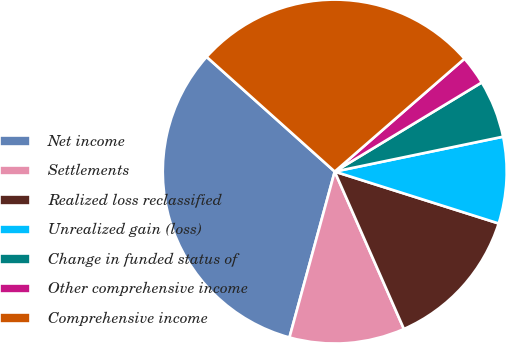<chart> <loc_0><loc_0><loc_500><loc_500><pie_chart><fcel>Net income<fcel>Settlements<fcel>Realized loss reclassified<fcel>Unrealized gain (loss)<fcel>Change in funded status of<fcel>Other comprehensive income<fcel>Comprehensive income<nl><fcel>32.38%<fcel>10.83%<fcel>13.53%<fcel>8.13%<fcel>5.42%<fcel>2.72%<fcel>26.98%<nl></chart> 